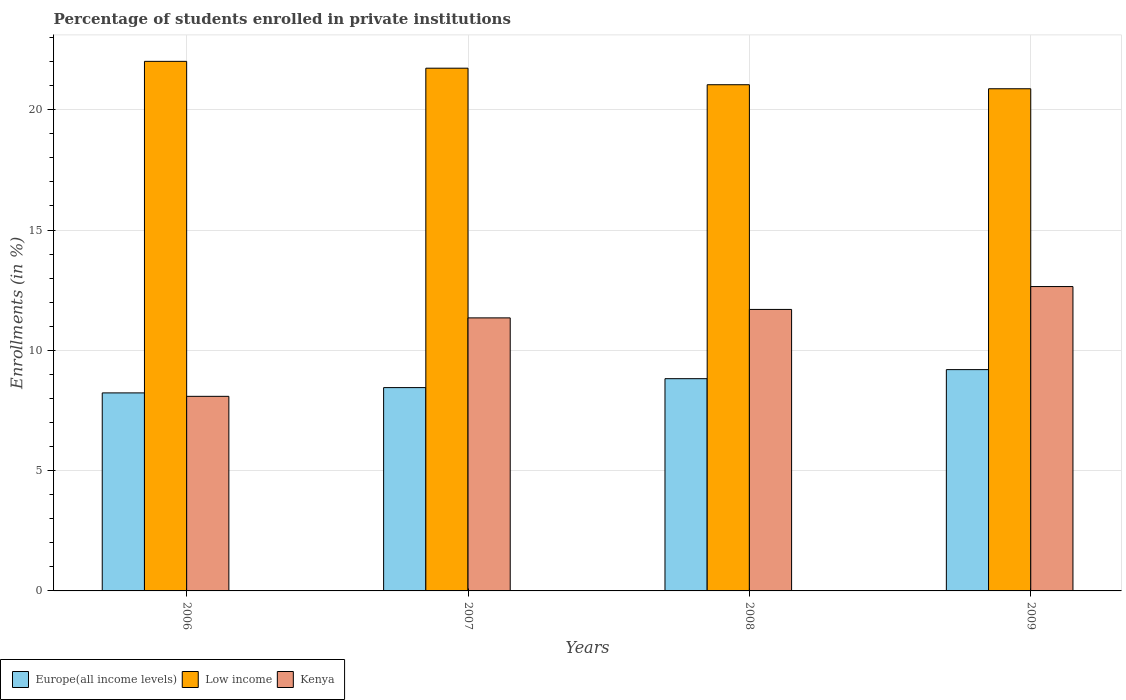How many groups of bars are there?
Your response must be concise. 4. Are the number of bars per tick equal to the number of legend labels?
Give a very brief answer. Yes. How many bars are there on the 1st tick from the left?
Make the answer very short. 3. What is the percentage of trained teachers in Kenya in 2009?
Make the answer very short. 12.65. Across all years, what is the maximum percentage of trained teachers in Europe(all income levels)?
Your answer should be very brief. 9.2. Across all years, what is the minimum percentage of trained teachers in Europe(all income levels)?
Ensure brevity in your answer.  8.23. In which year was the percentage of trained teachers in Kenya maximum?
Your answer should be compact. 2009. What is the total percentage of trained teachers in Kenya in the graph?
Offer a very short reply. 43.79. What is the difference between the percentage of trained teachers in Low income in 2006 and that in 2008?
Make the answer very short. 0.97. What is the difference between the percentage of trained teachers in Low income in 2008 and the percentage of trained teachers in Europe(all income levels) in 2006?
Give a very brief answer. 12.81. What is the average percentage of trained teachers in Europe(all income levels) per year?
Give a very brief answer. 8.68. In the year 2006, what is the difference between the percentage of trained teachers in Europe(all income levels) and percentage of trained teachers in Kenya?
Your answer should be compact. 0.14. What is the ratio of the percentage of trained teachers in Low income in 2006 to that in 2008?
Offer a terse response. 1.05. Is the difference between the percentage of trained teachers in Europe(all income levels) in 2006 and 2007 greater than the difference between the percentage of trained teachers in Kenya in 2006 and 2007?
Offer a very short reply. Yes. What is the difference between the highest and the second highest percentage of trained teachers in Low income?
Give a very brief answer. 0.28. What is the difference between the highest and the lowest percentage of trained teachers in Low income?
Your answer should be very brief. 1.14. In how many years, is the percentage of trained teachers in Europe(all income levels) greater than the average percentage of trained teachers in Europe(all income levels) taken over all years?
Your response must be concise. 2. Is the sum of the percentage of trained teachers in Low income in 2006 and 2007 greater than the maximum percentage of trained teachers in Kenya across all years?
Keep it short and to the point. Yes. What does the 1st bar from the left in 2009 represents?
Your answer should be compact. Europe(all income levels). What does the 2nd bar from the right in 2008 represents?
Offer a very short reply. Low income. Is it the case that in every year, the sum of the percentage of trained teachers in Low income and percentage of trained teachers in Kenya is greater than the percentage of trained teachers in Europe(all income levels)?
Your answer should be very brief. Yes. How many bars are there?
Offer a very short reply. 12. Are all the bars in the graph horizontal?
Provide a short and direct response. No. How many years are there in the graph?
Provide a short and direct response. 4. What is the difference between two consecutive major ticks on the Y-axis?
Keep it short and to the point. 5. Are the values on the major ticks of Y-axis written in scientific E-notation?
Provide a short and direct response. No. Does the graph contain any zero values?
Your response must be concise. No. Does the graph contain grids?
Ensure brevity in your answer.  Yes. Where does the legend appear in the graph?
Provide a short and direct response. Bottom left. How are the legend labels stacked?
Your answer should be compact. Horizontal. What is the title of the graph?
Provide a succinct answer. Percentage of students enrolled in private institutions. Does "Virgin Islands" appear as one of the legend labels in the graph?
Give a very brief answer. No. What is the label or title of the X-axis?
Your response must be concise. Years. What is the label or title of the Y-axis?
Give a very brief answer. Enrollments (in %). What is the Enrollments (in %) in Europe(all income levels) in 2006?
Provide a short and direct response. 8.23. What is the Enrollments (in %) of Low income in 2006?
Offer a terse response. 22.01. What is the Enrollments (in %) of Kenya in 2006?
Offer a very short reply. 8.09. What is the Enrollments (in %) in Europe(all income levels) in 2007?
Ensure brevity in your answer.  8.45. What is the Enrollments (in %) in Low income in 2007?
Provide a short and direct response. 21.73. What is the Enrollments (in %) in Kenya in 2007?
Your answer should be very brief. 11.35. What is the Enrollments (in %) of Europe(all income levels) in 2008?
Your response must be concise. 8.82. What is the Enrollments (in %) of Low income in 2008?
Offer a very short reply. 21.04. What is the Enrollments (in %) in Kenya in 2008?
Offer a terse response. 11.7. What is the Enrollments (in %) in Europe(all income levels) in 2009?
Your response must be concise. 9.2. What is the Enrollments (in %) in Low income in 2009?
Offer a terse response. 20.87. What is the Enrollments (in %) of Kenya in 2009?
Your answer should be compact. 12.65. Across all years, what is the maximum Enrollments (in %) in Europe(all income levels)?
Your response must be concise. 9.2. Across all years, what is the maximum Enrollments (in %) of Low income?
Your response must be concise. 22.01. Across all years, what is the maximum Enrollments (in %) of Kenya?
Offer a terse response. 12.65. Across all years, what is the minimum Enrollments (in %) in Europe(all income levels)?
Provide a short and direct response. 8.23. Across all years, what is the minimum Enrollments (in %) of Low income?
Provide a short and direct response. 20.87. Across all years, what is the minimum Enrollments (in %) of Kenya?
Give a very brief answer. 8.09. What is the total Enrollments (in %) of Europe(all income levels) in the graph?
Provide a succinct answer. 34.7. What is the total Enrollments (in %) in Low income in the graph?
Give a very brief answer. 85.65. What is the total Enrollments (in %) of Kenya in the graph?
Provide a succinct answer. 43.79. What is the difference between the Enrollments (in %) in Europe(all income levels) in 2006 and that in 2007?
Your answer should be compact. -0.22. What is the difference between the Enrollments (in %) in Low income in 2006 and that in 2007?
Offer a terse response. 0.28. What is the difference between the Enrollments (in %) of Kenya in 2006 and that in 2007?
Your answer should be compact. -3.26. What is the difference between the Enrollments (in %) of Europe(all income levels) in 2006 and that in 2008?
Keep it short and to the point. -0.59. What is the difference between the Enrollments (in %) in Low income in 2006 and that in 2008?
Provide a short and direct response. 0.97. What is the difference between the Enrollments (in %) in Kenya in 2006 and that in 2008?
Keep it short and to the point. -3.61. What is the difference between the Enrollments (in %) in Europe(all income levels) in 2006 and that in 2009?
Keep it short and to the point. -0.97. What is the difference between the Enrollments (in %) of Low income in 2006 and that in 2009?
Your answer should be compact. 1.14. What is the difference between the Enrollments (in %) in Kenya in 2006 and that in 2009?
Offer a terse response. -4.56. What is the difference between the Enrollments (in %) of Europe(all income levels) in 2007 and that in 2008?
Your answer should be compact. -0.37. What is the difference between the Enrollments (in %) of Low income in 2007 and that in 2008?
Provide a short and direct response. 0.69. What is the difference between the Enrollments (in %) in Kenya in 2007 and that in 2008?
Offer a very short reply. -0.35. What is the difference between the Enrollments (in %) of Europe(all income levels) in 2007 and that in 2009?
Keep it short and to the point. -0.75. What is the difference between the Enrollments (in %) in Low income in 2007 and that in 2009?
Your answer should be compact. 0.85. What is the difference between the Enrollments (in %) in Kenya in 2007 and that in 2009?
Give a very brief answer. -1.3. What is the difference between the Enrollments (in %) of Europe(all income levels) in 2008 and that in 2009?
Your response must be concise. -0.38. What is the difference between the Enrollments (in %) in Low income in 2008 and that in 2009?
Your answer should be compact. 0.17. What is the difference between the Enrollments (in %) in Kenya in 2008 and that in 2009?
Your answer should be compact. -0.95. What is the difference between the Enrollments (in %) of Europe(all income levels) in 2006 and the Enrollments (in %) of Low income in 2007?
Your answer should be compact. -13.5. What is the difference between the Enrollments (in %) of Europe(all income levels) in 2006 and the Enrollments (in %) of Kenya in 2007?
Your answer should be compact. -3.12. What is the difference between the Enrollments (in %) in Low income in 2006 and the Enrollments (in %) in Kenya in 2007?
Your answer should be very brief. 10.66. What is the difference between the Enrollments (in %) in Europe(all income levels) in 2006 and the Enrollments (in %) in Low income in 2008?
Give a very brief answer. -12.81. What is the difference between the Enrollments (in %) in Europe(all income levels) in 2006 and the Enrollments (in %) in Kenya in 2008?
Give a very brief answer. -3.47. What is the difference between the Enrollments (in %) in Low income in 2006 and the Enrollments (in %) in Kenya in 2008?
Your answer should be very brief. 10.31. What is the difference between the Enrollments (in %) in Europe(all income levels) in 2006 and the Enrollments (in %) in Low income in 2009?
Your answer should be very brief. -12.64. What is the difference between the Enrollments (in %) in Europe(all income levels) in 2006 and the Enrollments (in %) in Kenya in 2009?
Give a very brief answer. -4.42. What is the difference between the Enrollments (in %) in Low income in 2006 and the Enrollments (in %) in Kenya in 2009?
Offer a terse response. 9.36. What is the difference between the Enrollments (in %) of Europe(all income levels) in 2007 and the Enrollments (in %) of Low income in 2008?
Offer a very short reply. -12.59. What is the difference between the Enrollments (in %) of Europe(all income levels) in 2007 and the Enrollments (in %) of Kenya in 2008?
Give a very brief answer. -3.25. What is the difference between the Enrollments (in %) in Low income in 2007 and the Enrollments (in %) in Kenya in 2008?
Your answer should be compact. 10.03. What is the difference between the Enrollments (in %) in Europe(all income levels) in 2007 and the Enrollments (in %) in Low income in 2009?
Offer a very short reply. -12.42. What is the difference between the Enrollments (in %) of Europe(all income levels) in 2007 and the Enrollments (in %) of Kenya in 2009?
Make the answer very short. -4.2. What is the difference between the Enrollments (in %) in Low income in 2007 and the Enrollments (in %) in Kenya in 2009?
Ensure brevity in your answer.  9.08. What is the difference between the Enrollments (in %) of Europe(all income levels) in 2008 and the Enrollments (in %) of Low income in 2009?
Provide a succinct answer. -12.05. What is the difference between the Enrollments (in %) in Europe(all income levels) in 2008 and the Enrollments (in %) in Kenya in 2009?
Keep it short and to the point. -3.83. What is the difference between the Enrollments (in %) in Low income in 2008 and the Enrollments (in %) in Kenya in 2009?
Your response must be concise. 8.39. What is the average Enrollments (in %) of Europe(all income levels) per year?
Keep it short and to the point. 8.68. What is the average Enrollments (in %) in Low income per year?
Ensure brevity in your answer.  21.41. What is the average Enrollments (in %) of Kenya per year?
Your response must be concise. 10.95. In the year 2006, what is the difference between the Enrollments (in %) in Europe(all income levels) and Enrollments (in %) in Low income?
Provide a short and direct response. -13.78. In the year 2006, what is the difference between the Enrollments (in %) of Europe(all income levels) and Enrollments (in %) of Kenya?
Provide a short and direct response. 0.14. In the year 2006, what is the difference between the Enrollments (in %) of Low income and Enrollments (in %) of Kenya?
Your answer should be compact. 13.92. In the year 2007, what is the difference between the Enrollments (in %) of Europe(all income levels) and Enrollments (in %) of Low income?
Ensure brevity in your answer.  -13.28. In the year 2007, what is the difference between the Enrollments (in %) of Europe(all income levels) and Enrollments (in %) of Kenya?
Offer a terse response. -2.9. In the year 2007, what is the difference between the Enrollments (in %) of Low income and Enrollments (in %) of Kenya?
Ensure brevity in your answer.  10.38. In the year 2008, what is the difference between the Enrollments (in %) in Europe(all income levels) and Enrollments (in %) in Low income?
Your response must be concise. -12.22. In the year 2008, what is the difference between the Enrollments (in %) in Europe(all income levels) and Enrollments (in %) in Kenya?
Give a very brief answer. -2.88. In the year 2008, what is the difference between the Enrollments (in %) in Low income and Enrollments (in %) in Kenya?
Your response must be concise. 9.34. In the year 2009, what is the difference between the Enrollments (in %) of Europe(all income levels) and Enrollments (in %) of Low income?
Offer a very short reply. -11.67. In the year 2009, what is the difference between the Enrollments (in %) in Europe(all income levels) and Enrollments (in %) in Kenya?
Make the answer very short. -3.45. In the year 2009, what is the difference between the Enrollments (in %) of Low income and Enrollments (in %) of Kenya?
Offer a very short reply. 8.22. What is the ratio of the Enrollments (in %) in Europe(all income levels) in 2006 to that in 2007?
Your answer should be compact. 0.97. What is the ratio of the Enrollments (in %) in Low income in 2006 to that in 2007?
Your answer should be very brief. 1.01. What is the ratio of the Enrollments (in %) of Kenya in 2006 to that in 2007?
Your response must be concise. 0.71. What is the ratio of the Enrollments (in %) of Europe(all income levels) in 2006 to that in 2008?
Ensure brevity in your answer.  0.93. What is the ratio of the Enrollments (in %) in Low income in 2006 to that in 2008?
Ensure brevity in your answer.  1.05. What is the ratio of the Enrollments (in %) of Kenya in 2006 to that in 2008?
Your answer should be very brief. 0.69. What is the ratio of the Enrollments (in %) of Europe(all income levels) in 2006 to that in 2009?
Your response must be concise. 0.89. What is the ratio of the Enrollments (in %) in Low income in 2006 to that in 2009?
Give a very brief answer. 1.05. What is the ratio of the Enrollments (in %) of Kenya in 2006 to that in 2009?
Provide a succinct answer. 0.64. What is the ratio of the Enrollments (in %) of Europe(all income levels) in 2007 to that in 2008?
Provide a succinct answer. 0.96. What is the ratio of the Enrollments (in %) of Low income in 2007 to that in 2008?
Your answer should be compact. 1.03. What is the ratio of the Enrollments (in %) of Europe(all income levels) in 2007 to that in 2009?
Provide a short and direct response. 0.92. What is the ratio of the Enrollments (in %) of Low income in 2007 to that in 2009?
Keep it short and to the point. 1.04. What is the ratio of the Enrollments (in %) in Kenya in 2007 to that in 2009?
Offer a terse response. 0.9. What is the ratio of the Enrollments (in %) of Europe(all income levels) in 2008 to that in 2009?
Provide a succinct answer. 0.96. What is the ratio of the Enrollments (in %) in Kenya in 2008 to that in 2009?
Your answer should be compact. 0.92. What is the difference between the highest and the second highest Enrollments (in %) of Europe(all income levels)?
Your answer should be compact. 0.38. What is the difference between the highest and the second highest Enrollments (in %) in Low income?
Provide a short and direct response. 0.28. What is the difference between the highest and the second highest Enrollments (in %) in Kenya?
Provide a succinct answer. 0.95. What is the difference between the highest and the lowest Enrollments (in %) of Europe(all income levels)?
Make the answer very short. 0.97. What is the difference between the highest and the lowest Enrollments (in %) in Low income?
Keep it short and to the point. 1.14. What is the difference between the highest and the lowest Enrollments (in %) in Kenya?
Your response must be concise. 4.56. 